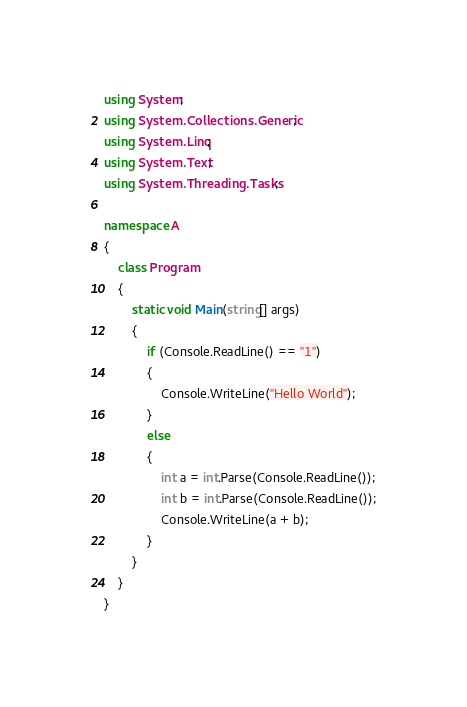<code> <loc_0><loc_0><loc_500><loc_500><_C#_>using System;
using System.Collections.Generic;
using System.Linq;
using System.Text;
using System.Threading.Tasks;

namespace A
{
    class Program
    {
        static void Main(string[] args)
        {
            if (Console.ReadLine() == "1")
            {
                Console.WriteLine("Hello World");
            }
            else
            {
                int a = int.Parse(Console.ReadLine());
                int b = int.Parse(Console.ReadLine());
                Console.WriteLine(a + b);
            }
        }
    }
}
</code> 